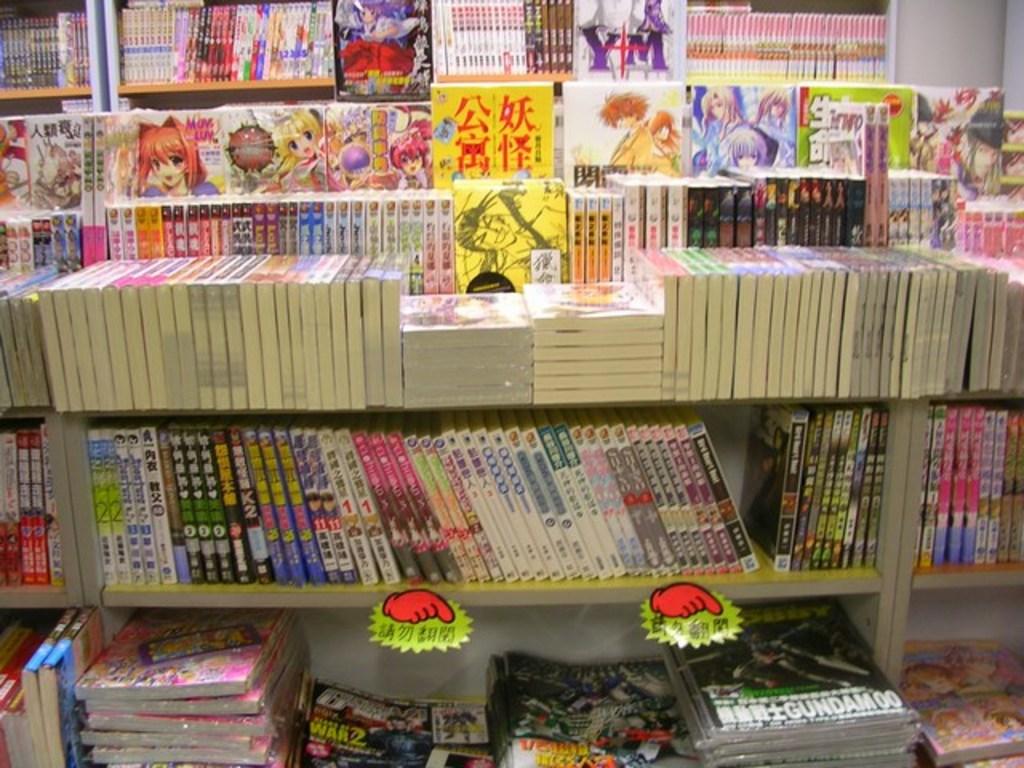The bottom right magazine has a robot called what on the cover?
Your response must be concise. Gundam. Are these books graphic novels?
Make the answer very short. Yes. 